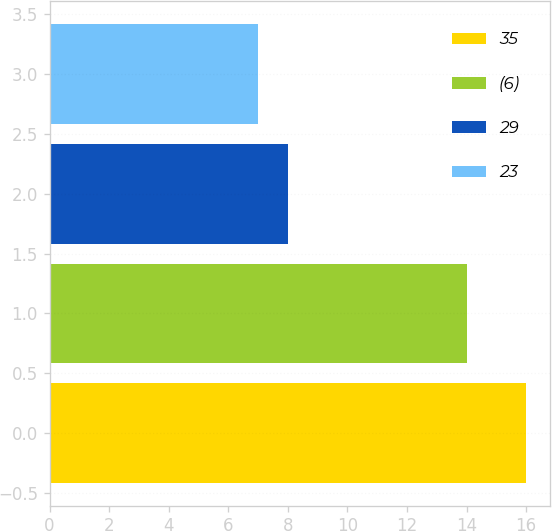<chart> <loc_0><loc_0><loc_500><loc_500><bar_chart><fcel>35<fcel>(6)<fcel>29<fcel>23<nl><fcel>16<fcel>14<fcel>8<fcel>7<nl></chart> 